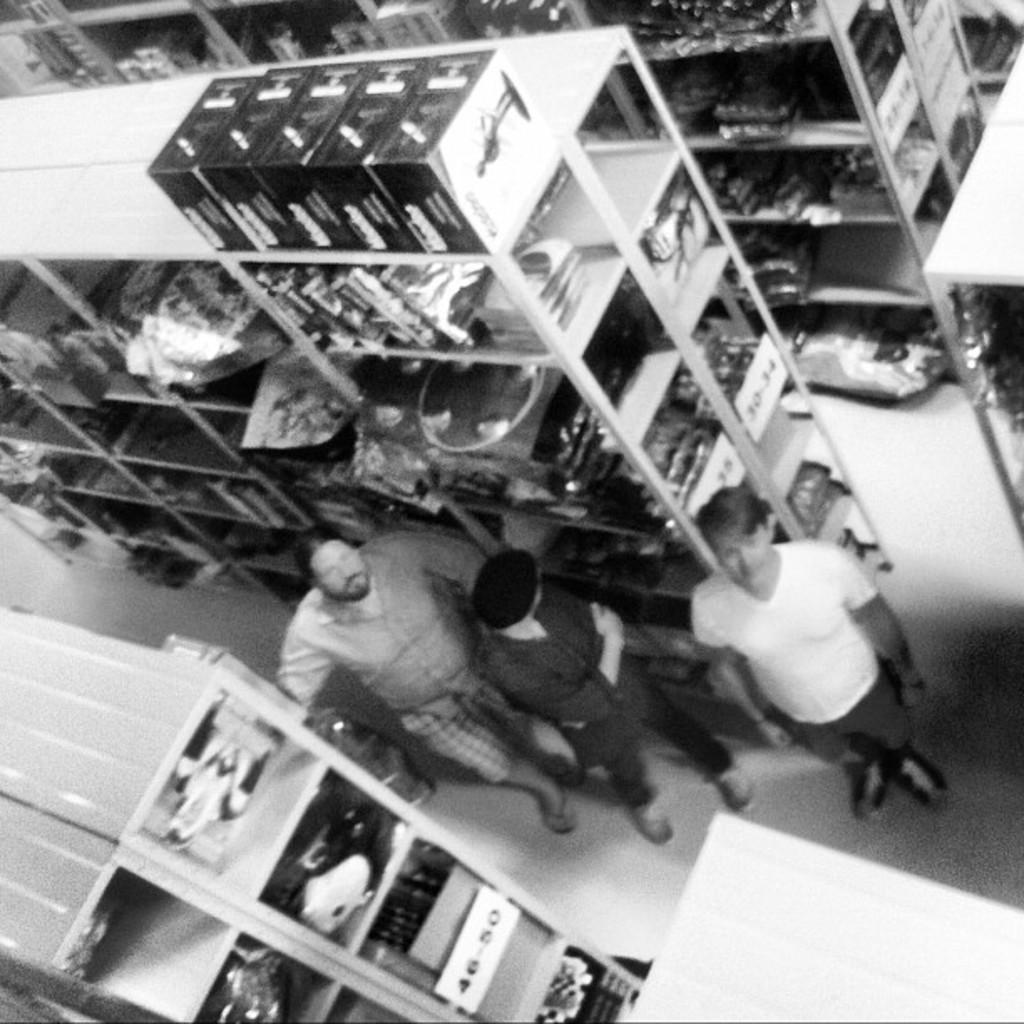What is the color scheme of the image? The image is black and white. What type of furniture is present in the room? There are cabinets in the room. How are the cabinets organized? Each shelf of the cabinet has objects placed on it. How many people are in the image? There are three men in the picture. What type of cars are parked on the rail route in the image? There are no cars or rail routes present in the image; it features a black and white scene with cabinets and objects on shelves. 